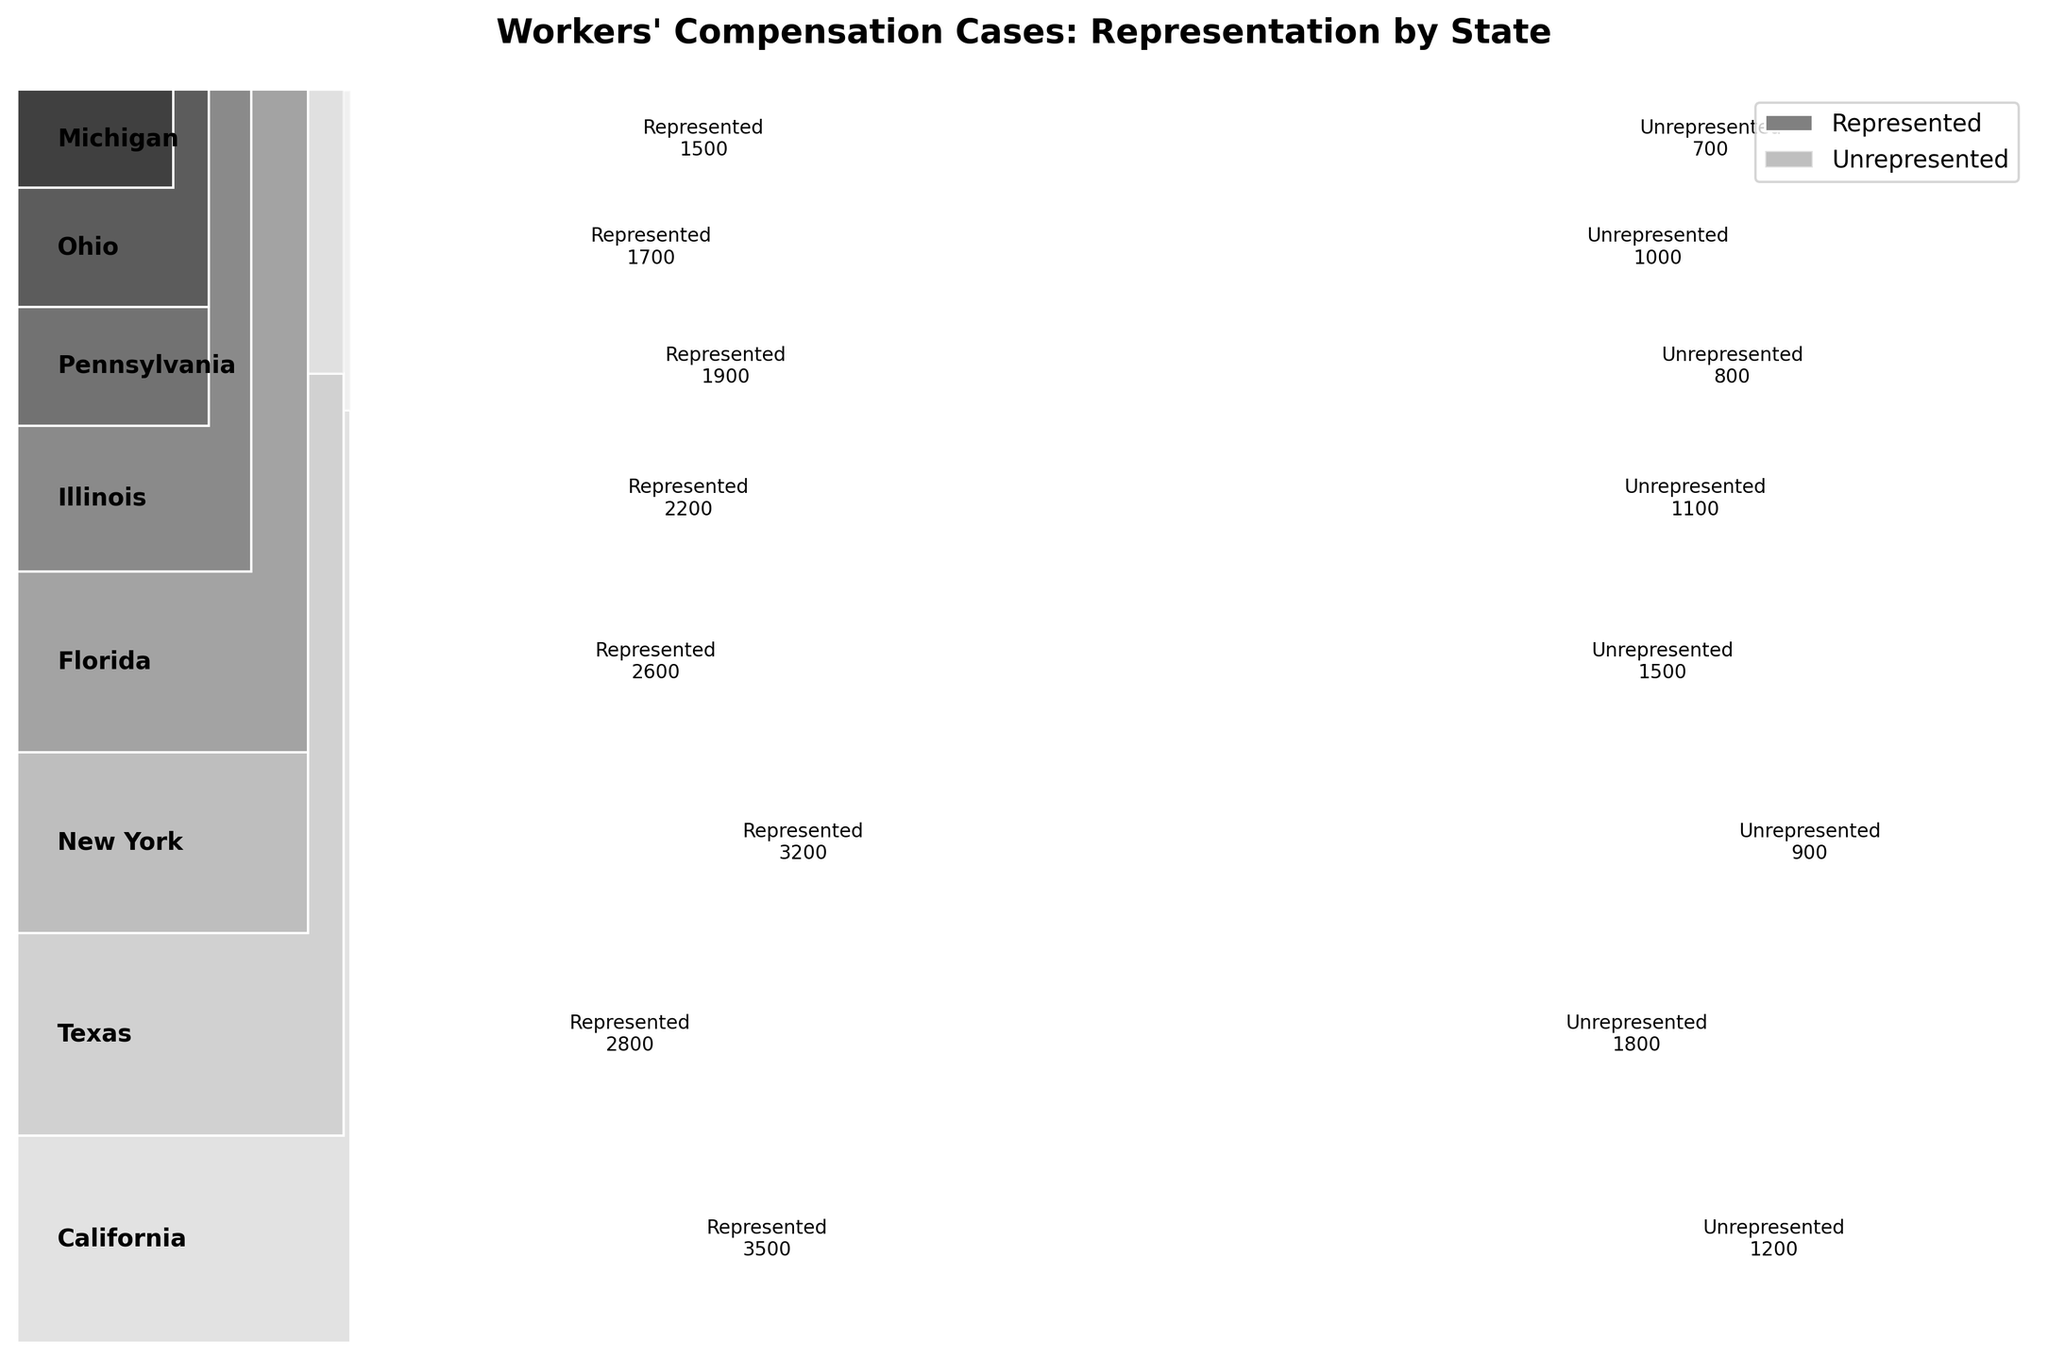what is the title of the plot? The title of the plot is usually located at the top of the figure and is written in a larger font size compared to other text elements. For this particular plot, the title provides a general description of the content being visualized.
Answer: Workers' Compensation Cases: Representation by State Which state has the highest number of represented cases? The number of represented cases for each state can be identified by looking at the labels on the rectangles representing each state. The state with the highest number will have the largest area labeled "Represented" within its corresponding rectangle.
Answer: California Which state has the smallest difference between represented and unrepresented cases? To find the state with the smallest difference, one needs to compare the lengths of the "Represented" and "Unrepresented" regions for each state. The state with the closest lengths will have the smallest difference.
Answer: Ohio What is the total number of workers' compensation cases in New York? The total number is obtained by summing the represented and unrepresented cases for New York. This is visually represented by the combined height of the two rectangles labeled "Represented" and "Unrepresented" under New York.
Answer: 4100 Which state has the highest proportion of unrepresented cases relative to the total number of cases in that state? Visually, this can be assessed by comparing the heights of rectangles labeled "Unrepresented" to the total combined height of rectangles for each state. The state with the largest relative height for "Unrepresented" has the highest proportion of unrepresented cases.
Answer: Texas Compare the number of represented cases between California and Texas. Which state has more represented cases? By comparing the sizes of the rectangles labeled "Represented" for California and Texas, one can identify which state has more represented cases. California's "Represented" area is larger than Texas's.
Answer: California What is the combined number of unrepresented cases in Illinois and Michigan? Add the unrepresented cases for Illinois and Michigan by locating the corresponding labels on the plot and summing them. For Illinois, it's 1100, and for Michigan, it's 700. Thus, combined: 1100 + 700.
Answer: 1800 Which two states have the most similar proportions of represented cases? By visually comparing the heights of rectangles labeled "Represented" across states in relation to their overall combined heights, one can identify the states with similar proportions.
Answer: Pennsylvania and Ohio How does the number of represented cases in New York compare to the represented cases in Florida? Comparing the sizes of the rectangles labeled "Represented" for New York and Florida allows one to see that New York has a larger "Represented" area compared to Florida.
Answer: New York has more represented cases What is the ratio of represented to unrepresented cases in Pennsylvania? To find the ratio, divide the number of represented cases by the number of unrepresented cases in Pennsylvania. Represented: 1900, Unrepresented: 800. Ratio = 1900 / 800.
Answer: 2.375 